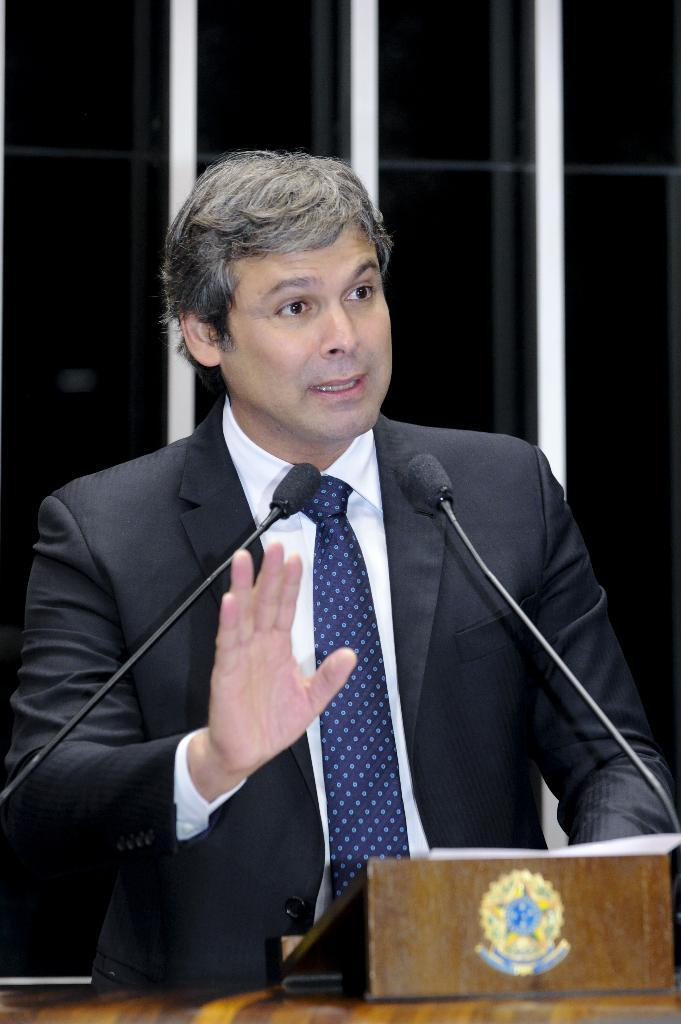What is the main object in the image? There is a table in the image. Can you describe the man in the image? There is a man wearing a black jacket in the image. What type of animals are present in the image? There are mice in the image. What else can be seen on the table? There is a box in the image. How would you describe the lighting in the image? The image is slightly dark. What channel is the man watching on the television in the image? There is no television present in the image; it only features a table, a man wearing a black jacket, mice, and a box. 